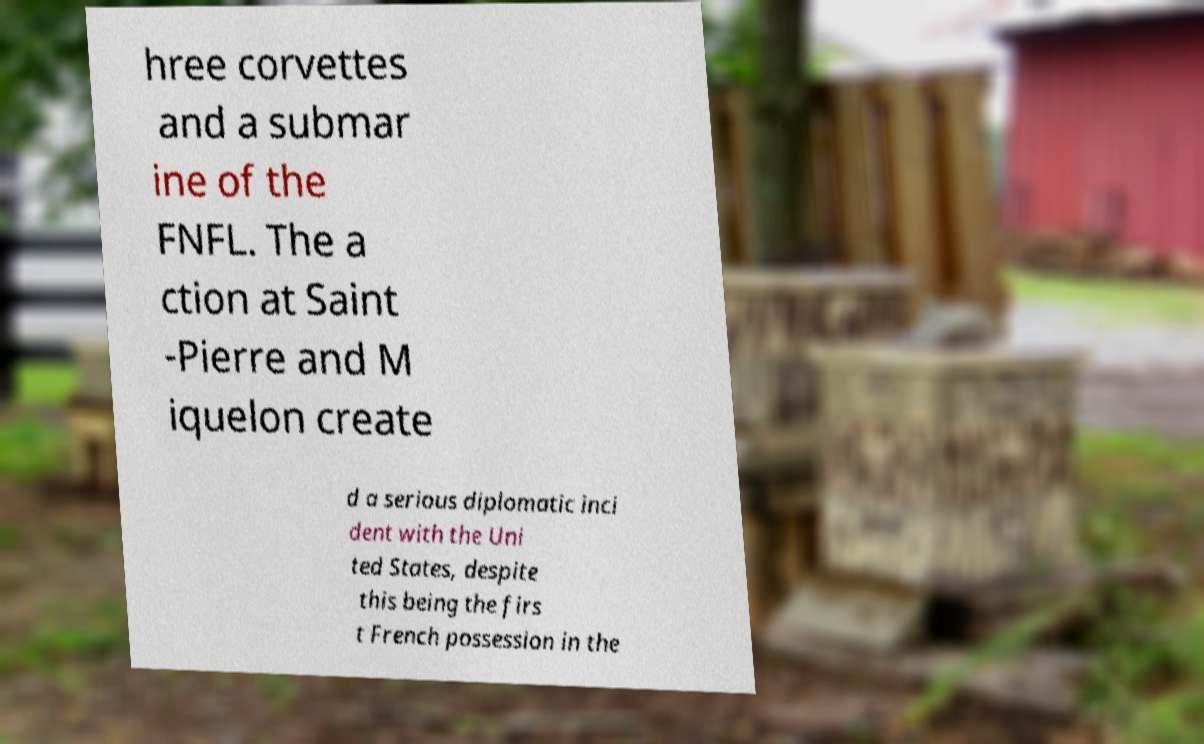For documentation purposes, I need the text within this image transcribed. Could you provide that? hree corvettes and a submar ine of the FNFL. The a ction at Saint -Pierre and M iquelon create d a serious diplomatic inci dent with the Uni ted States, despite this being the firs t French possession in the 